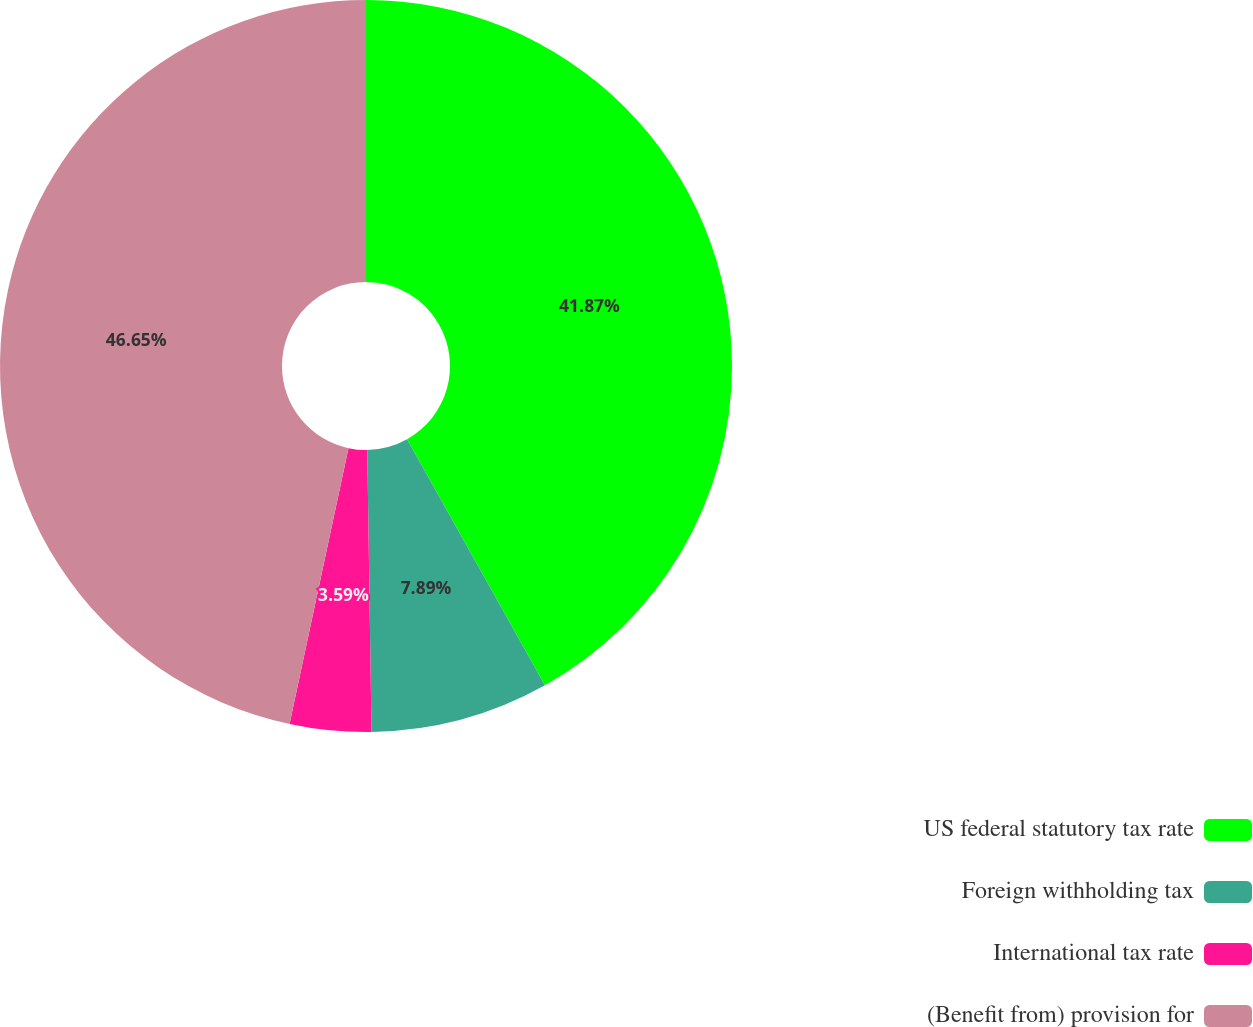<chart> <loc_0><loc_0><loc_500><loc_500><pie_chart><fcel>US federal statutory tax rate<fcel>Foreign withholding tax<fcel>International tax rate<fcel>(Benefit from) provision for<nl><fcel>41.87%<fcel>7.89%<fcel>3.59%<fcel>46.65%<nl></chart> 